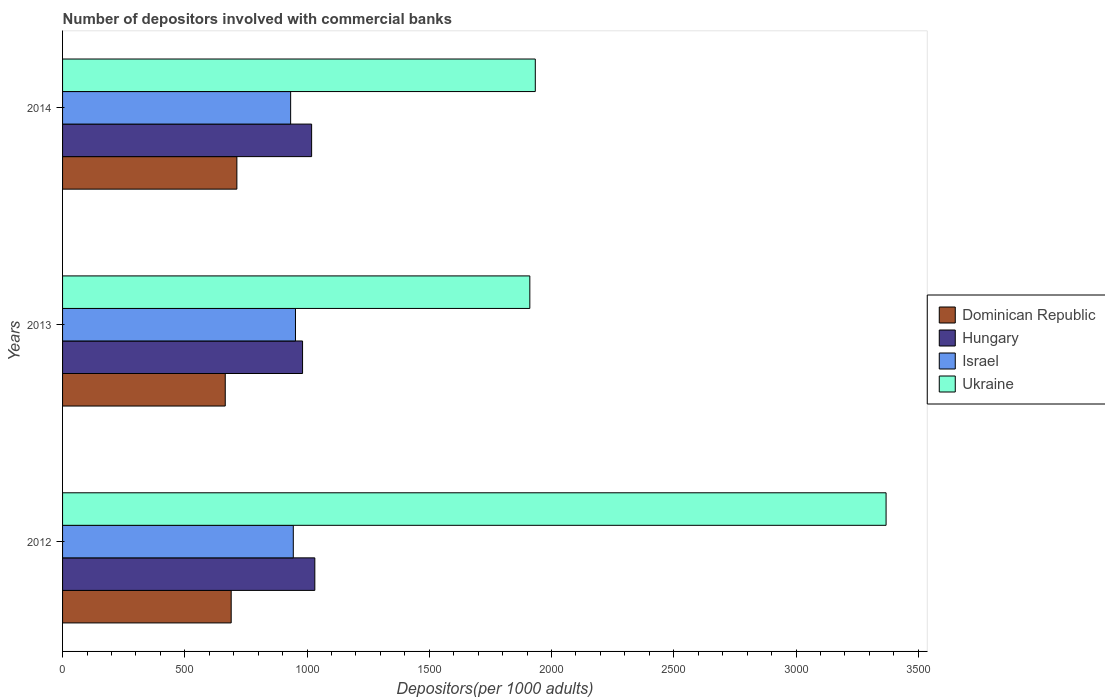How many different coloured bars are there?
Provide a succinct answer. 4. Are the number of bars on each tick of the Y-axis equal?
Keep it short and to the point. Yes. What is the number of depositors involved with commercial banks in Hungary in 2013?
Your answer should be compact. 981.67. Across all years, what is the maximum number of depositors involved with commercial banks in Ukraine?
Give a very brief answer. 3368.39. Across all years, what is the minimum number of depositors involved with commercial banks in Ukraine?
Offer a terse response. 1911.24. In which year was the number of depositors involved with commercial banks in Israel maximum?
Your answer should be compact. 2013. In which year was the number of depositors involved with commercial banks in Hungary minimum?
Provide a succinct answer. 2013. What is the total number of depositors involved with commercial banks in Hungary in the graph?
Your response must be concise. 3032.23. What is the difference between the number of depositors involved with commercial banks in Israel in 2012 and that in 2014?
Provide a succinct answer. 10.87. What is the difference between the number of depositors involved with commercial banks in Israel in 2014 and the number of depositors involved with commercial banks in Ukraine in 2013?
Keep it short and to the point. -978.38. What is the average number of depositors involved with commercial banks in Hungary per year?
Your answer should be very brief. 1010.74. In the year 2014, what is the difference between the number of depositors involved with commercial banks in Ukraine and number of depositors involved with commercial banks in Israel?
Give a very brief answer. 1000.7. In how many years, is the number of depositors involved with commercial banks in Hungary greater than 3200 ?
Your response must be concise. 0. What is the ratio of the number of depositors involved with commercial banks in Dominican Republic in 2012 to that in 2013?
Your answer should be very brief. 1.04. Is the number of depositors involved with commercial banks in Dominican Republic in 2012 less than that in 2014?
Your response must be concise. Yes. What is the difference between the highest and the second highest number of depositors involved with commercial banks in Hungary?
Give a very brief answer. 13.07. What is the difference between the highest and the lowest number of depositors involved with commercial banks in Hungary?
Give a very brief answer. 50.15. In how many years, is the number of depositors involved with commercial banks in Dominican Republic greater than the average number of depositors involved with commercial banks in Dominican Republic taken over all years?
Give a very brief answer. 2. What does the 4th bar from the bottom in 2012 represents?
Give a very brief answer. Ukraine. Is it the case that in every year, the sum of the number of depositors involved with commercial banks in Ukraine and number of depositors involved with commercial banks in Dominican Republic is greater than the number of depositors involved with commercial banks in Hungary?
Keep it short and to the point. Yes. Are all the bars in the graph horizontal?
Make the answer very short. Yes. Are the values on the major ticks of X-axis written in scientific E-notation?
Offer a terse response. No. Does the graph contain any zero values?
Ensure brevity in your answer.  No. How are the legend labels stacked?
Keep it short and to the point. Vertical. What is the title of the graph?
Your response must be concise. Number of depositors involved with commercial banks. What is the label or title of the X-axis?
Make the answer very short. Depositors(per 1000 adults). What is the label or title of the Y-axis?
Offer a terse response. Years. What is the Depositors(per 1000 adults) in Dominican Republic in 2012?
Provide a succinct answer. 689.69. What is the Depositors(per 1000 adults) in Hungary in 2012?
Offer a terse response. 1031.82. What is the Depositors(per 1000 adults) of Israel in 2012?
Keep it short and to the point. 943.72. What is the Depositors(per 1000 adults) in Ukraine in 2012?
Provide a short and direct response. 3368.39. What is the Depositors(per 1000 adults) in Dominican Republic in 2013?
Your response must be concise. 665.43. What is the Depositors(per 1000 adults) of Hungary in 2013?
Make the answer very short. 981.67. What is the Depositors(per 1000 adults) of Israel in 2013?
Ensure brevity in your answer.  952.62. What is the Depositors(per 1000 adults) in Ukraine in 2013?
Keep it short and to the point. 1911.24. What is the Depositors(per 1000 adults) in Dominican Republic in 2014?
Offer a very short reply. 712.97. What is the Depositors(per 1000 adults) in Hungary in 2014?
Ensure brevity in your answer.  1018.74. What is the Depositors(per 1000 adults) of Israel in 2014?
Your response must be concise. 932.86. What is the Depositors(per 1000 adults) of Ukraine in 2014?
Give a very brief answer. 1933.56. Across all years, what is the maximum Depositors(per 1000 adults) in Dominican Republic?
Provide a succinct answer. 712.97. Across all years, what is the maximum Depositors(per 1000 adults) in Hungary?
Your response must be concise. 1031.82. Across all years, what is the maximum Depositors(per 1000 adults) in Israel?
Give a very brief answer. 952.62. Across all years, what is the maximum Depositors(per 1000 adults) in Ukraine?
Offer a terse response. 3368.39. Across all years, what is the minimum Depositors(per 1000 adults) of Dominican Republic?
Offer a terse response. 665.43. Across all years, what is the minimum Depositors(per 1000 adults) of Hungary?
Make the answer very short. 981.67. Across all years, what is the minimum Depositors(per 1000 adults) in Israel?
Keep it short and to the point. 932.86. Across all years, what is the minimum Depositors(per 1000 adults) of Ukraine?
Give a very brief answer. 1911.24. What is the total Depositors(per 1000 adults) of Dominican Republic in the graph?
Give a very brief answer. 2068.09. What is the total Depositors(per 1000 adults) in Hungary in the graph?
Provide a short and direct response. 3032.23. What is the total Depositors(per 1000 adults) of Israel in the graph?
Keep it short and to the point. 2829.2. What is the total Depositors(per 1000 adults) of Ukraine in the graph?
Your answer should be very brief. 7213.18. What is the difference between the Depositors(per 1000 adults) in Dominican Republic in 2012 and that in 2013?
Your answer should be compact. 24.27. What is the difference between the Depositors(per 1000 adults) of Hungary in 2012 and that in 2013?
Make the answer very short. 50.15. What is the difference between the Depositors(per 1000 adults) in Israel in 2012 and that in 2013?
Your answer should be very brief. -8.9. What is the difference between the Depositors(per 1000 adults) in Ukraine in 2012 and that in 2013?
Your answer should be compact. 1457.15. What is the difference between the Depositors(per 1000 adults) in Dominican Republic in 2012 and that in 2014?
Offer a very short reply. -23.27. What is the difference between the Depositors(per 1000 adults) of Hungary in 2012 and that in 2014?
Offer a very short reply. 13.07. What is the difference between the Depositors(per 1000 adults) of Israel in 2012 and that in 2014?
Make the answer very short. 10.87. What is the difference between the Depositors(per 1000 adults) of Ukraine in 2012 and that in 2014?
Your answer should be very brief. 1434.83. What is the difference between the Depositors(per 1000 adults) of Dominican Republic in 2013 and that in 2014?
Make the answer very short. -47.54. What is the difference between the Depositors(per 1000 adults) in Hungary in 2013 and that in 2014?
Ensure brevity in your answer.  -37.07. What is the difference between the Depositors(per 1000 adults) of Israel in 2013 and that in 2014?
Make the answer very short. 19.76. What is the difference between the Depositors(per 1000 adults) in Ukraine in 2013 and that in 2014?
Your response must be concise. -22.32. What is the difference between the Depositors(per 1000 adults) in Dominican Republic in 2012 and the Depositors(per 1000 adults) in Hungary in 2013?
Make the answer very short. -291.97. What is the difference between the Depositors(per 1000 adults) in Dominican Republic in 2012 and the Depositors(per 1000 adults) in Israel in 2013?
Provide a short and direct response. -262.93. What is the difference between the Depositors(per 1000 adults) of Dominican Republic in 2012 and the Depositors(per 1000 adults) of Ukraine in 2013?
Provide a succinct answer. -1221.54. What is the difference between the Depositors(per 1000 adults) in Hungary in 2012 and the Depositors(per 1000 adults) in Israel in 2013?
Provide a succinct answer. 79.19. What is the difference between the Depositors(per 1000 adults) in Hungary in 2012 and the Depositors(per 1000 adults) in Ukraine in 2013?
Keep it short and to the point. -879.42. What is the difference between the Depositors(per 1000 adults) in Israel in 2012 and the Depositors(per 1000 adults) in Ukraine in 2013?
Offer a terse response. -967.51. What is the difference between the Depositors(per 1000 adults) in Dominican Republic in 2012 and the Depositors(per 1000 adults) in Hungary in 2014?
Give a very brief answer. -329.05. What is the difference between the Depositors(per 1000 adults) of Dominican Republic in 2012 and the Depositors(per 1000 adults) of Israel in 2014?
Make the answer very short. -243.16. What is the difference between the Depositors(per 1000 adults) in Dominican Republic in 2012 and the Depositors(per 1000 adults) in Ukraine in 2014?
Provide a succinct answer. -1243.86. What is the difference between the Depositors(per 1000 adults) in Hungary in 2012 and the Depositors(per 1000 adults) in Israel in 2014?
Offer a terse response. 98.96. What is the difference between the Depositors(per 1000 adults) in Hungary in 2012 and the Depositors(per 1000 adults) in Ukraine in 2014?
Provide a short and direct response. -901.74. What is the difference between the Depositors(per 1000 adults) of Israel in 2012 and the Depositors(per 1000 adults) of Ukraine in 2014?
Keep it short and to the point. -989.83. What is the difference between the Depositors(per 1000 adults) of Dominican Republic in 2013 and the Depositors(per 1000 adults) of Hungary in 2014?
Your answer should be very brief. -353.31. What is the difference between the Depositors(per 1000 adults) of Dominican Republic in 2013 and the Depositors(per 1000 adults) of Israel in 2014?
Make the answer very short. -267.43. What is the difference between the Depositors(per 1000 adults) of Dominican Republic in 2013 and the Depositors(per 1000 adults) of Ukraine in 2014?
Your answer should be compact. -1268.13. What is the difference between the Depositors(per 1000 adults) of Hungary in 2013 and the Depositors(per 1000 adults) of Israel in 2014?
Your answer should be very brief. 48.81. What is the difference between the Depositors(per 1000 adults) of Hungary in 2013 and the Depositors(per 1000 adults) of Ukraine in 2014?
Offer a terse response. -951.89. What is the difference between the Depositors(per 1000 adults) of Israel in 2013 and the Depositors(per 1000 adults) of Ukraine in 2014?
Provide a succinct answer. -980.94. What is the average Depositors(per 1000 adults) of Dominican Republic per year?
Offer a terse response. 689.36. What is the average Depositors(per 1000 adults) in Hungary per year?
Offer a very short reply. 1010.74. What is the average Depositors(per 1000 adults) in Israel per year?
Keep it short and to the point. 943.07. What is the average Depositors(per 1000 adults) in Ukraine per year?
Keep it short and to the point. 2404.39. In the year 2012, what is the difference between the Depositors(per 1000 adults) of Dominican Republic and Depositors(per 1000 adults) of Hungary?
Make the answer very short. -342.12. In the year 2012, what is the difference between the Depositors(per 1000 adults) of Dominican Republic and Depositors(per 1000 adults) of Israel?
Your response must be concise. -254.03. In the year 2012, what is the difference between the Depositors(per 1000 adults) in Dominican Republic and Depositors(per 1000 adults) in Ukraine?
Ensure brevity in your answer.  -2678.69. In the year 2012, what is the difference between the Depositors(per 1000 adults) in Hungary and Depositors(per 1000 adults) in Israel?
Your answer should be very brief. 88.09. In the year 2012, what is the difference between the Depositors(per 1000 adults) in Hungary and Depositors(per 1000 adults) in Ukraine?
Give a very brief answer. -2336.57. In the year 2012, what is the difference between the Depositors(per 1000 adults) in Israel and Depositors(per 1000 adults) in Ukraine?
Keep it short and to the point. -2424.66. In the year 2013, what is the difference between the Depositors(per 1000 adults) of Dominican Republic and Depositors(per 1000 adults) of Hungary?
Give a very brief answer. -316.24. In the year 2013, what is the difference between the Depositors(per 1000 adults) of Dominican Republic and Depositors(per 1000 adults) of Israel?
Offer a terse response. -287.19. In the year 2013, what is the difference between the Depositors(per 1000 adults) of Dominican Republic and Depositors(per 1000 adults) of Ukraine?
Your response must be concise. -1245.81. In the year 2013, what is the difference between the Depositors(per 1000 adults) of Hungary and Depositors(per 1000 adults) of Israel?
Your response must be concise. 29.05. In the year 2013, what is the difference between the Depositors(per 1000 adults) in Hungary and Depositors(per 1000 adults) in Ukraine?
Your response must be concise. -929.57. In the year 2013, what is the difference between the Depositors(per 1000 adults) of Israel and Depositors(per 1000 adults) of Ukraine?
Offer a terse response. -958.61. In the year 2014, what is the difference between the Depositors(per 1000 adults) of Dominican Republic and Depositors(per 1000 adults) of Hungary?
Your answer should be very brief. -305.78. In the year 2014, what is the difference between the Depositors(per 1000 adults) of Dominican Republic and Depositors(per 1000 adults) of Israel?
Ensure brevity in your answer.  -219.89. In the year 2014, what is the difference between the Depositors(per 1000 adults) of Dominican Republic and Depositors(per 1000 adults) of Ukraine?
Provide a short and direct response. -1220.59. In the year 2014, what is the difference between the Depositors(per 1000 adults) of Hungary and Depositors(per 1000 adults) of Israel?
Ensure brevity in your answer.  85.88. In the year 2014, what is the difference between the Depositors(per 1000 adults) of Hungary and Depositors(per 1000 adults) of Ukraine?
Make the answer very short. -914.82. In the year 2014, what is the difference between the Depositors(per 1000 adults) in Israel and Depositors(per 1000 adults) in Ukraine?
Offer a terse response. -1000.7. What is the ratio of the Depositors(per 1000 adults) of Dominican Republic in 2012 to that in 2013?
Keep it short and to the point. 1.04. What is the ratio of the Depositors(per 1000 adults) of Hungary in 2012 to that in 2013?
Make the answer very short. 1.05. What is the ratio of the Depositors(per 1000 adults) of Israel in 2012 to that in 2013?
Your response must be concise. 0.99. What is the ratio of the Depositors(per 1000 adults) of Ukraine in 2012 to that in 2013?
Your answer should be compact. 1.76. What is the ratio of the Depositors(per 1000 adults) of Dominican Republic in 2012 to that in 2014?
Provide a succinct answer. 0.97. What is the ratio of the Depositors(per 1000 adults) in Hungary in 2012 to that in 2014?
Offer a terse response. 1.01. What is the ratio of the Depositors(per 1000 adults) of Israel in 2012 to that in 2014?
Provide a succinct answer. 1.01. What is the ratio of the Depositors(per 1000 adults) of Ukraine in 2012 to that in 2014?
Your answer should be compact. 1.74. What is the ratio of the Depositors(per 1000 adults) in Dominican Republic in 2013 to that in 2014?
Offer a very short reply. 0.93. What is the ratio of the Depositors(per 1000 adults) of Hungary in 2013 to that in 2014?
Provide a succinct answer. 0.96. What is the ratio of the Depositors(per 1000 adults) in Israel in 2013 to that in 2014?
Your answer should be very brief. 1.02. What is the ratio of the Depositors(per 1000 adults) in Ukraine in 2013 to that in 2014?
Keep it short and to the point. 0.99. What is the difference between the highest and the second highest Depositors(per 1000 adults) in Dominican Republic?
Your answer should be very brief. 23.27. What is the difference between the highest and the second highest Depositors(per 1000 adults) of Hungary?
Ensure brevity in your answer.  13.07. What is the difference between the highest and the second highest Depositors(per 1000 adults) in Israel?
Keep it short and to the point. 8.9. What is the difference between the highest and the second highest Depositors(per 1000 adults) of Ukraine?
Provide a succinct answer. 1434.83. What is the difference between the highest and the lowest Depositors(per 1000 adults) of Dominican Republic?
Offer a very short reply. 47.54. What is the difference between the highest and the lowest Depositors(per 1000 adults) of Hungary?
Give a very brief answer. 50.15. What is the difference between the highest and the lowest Depositors(per 1000 adults) of Israel?
Offer a very short reply. 19.76. What is the difference between the highest and the lowest Depositors(per 1000 adults) in Ukraine?
Give a very brief answer. 1457.15. 